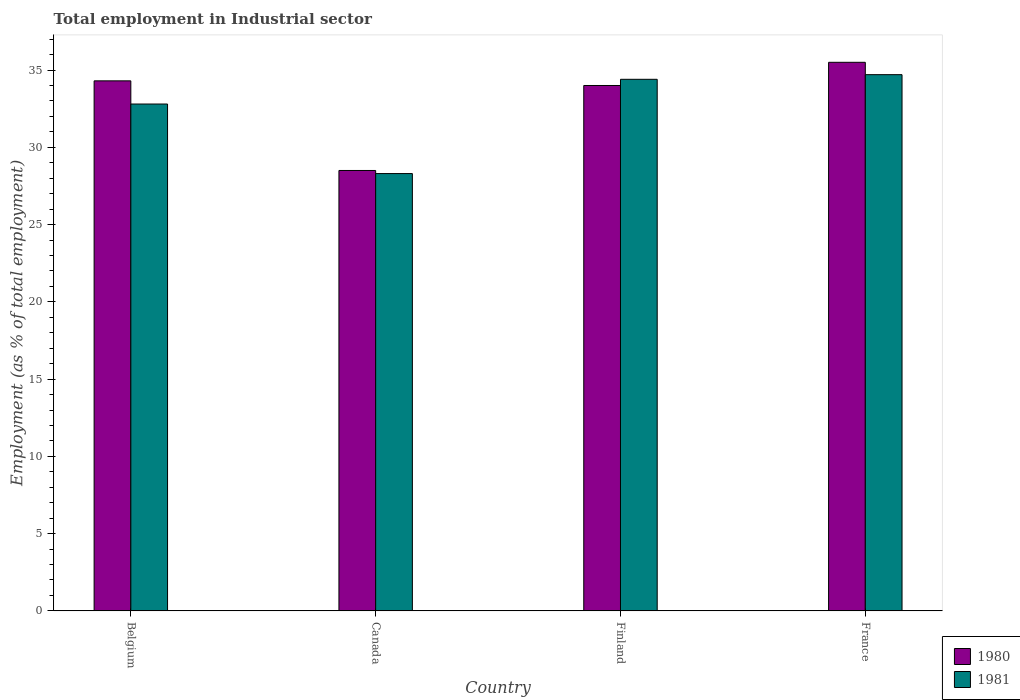How many different coloured bars are there?
Ensure brevity in your answer.  2. How many groups of bars are there?
Provide a succinct answer. 4. Are the number of bars per tick equal to the number of legend labels?
Your response must be concise. Yes. How many bars are there on the 2nd tick from the left?
Offer a very short reply. 2. How many bars are there on the 3rd tick from the right?
Provide a succinct answer. 2. In how many cases, is the number of bars for a given country not equal to the number of legend labels?
Provide a short and direct response. 0. What is the employment in industrial sector in 1981 in Canada?
Your response must be concise. 28.3. Across all countries, what is the maximum employment in industrial sector in 1981?
Give a very brief answer. 34.7. Across all countries, what is the minimum employment in industrial sector in 1981?
Your answer should be very brief. 28.3. What is the total employment in industrial sector in 1981 in the graph?
Provide a succinct answer. 130.2. What is the difference between the employment in industrial sector in 1981 in Belgium and that in France?
Keep it short and to the point. -1.9. What is the difference between the employment in industrial sector in 1981 in Finland and the employment in industrial sector in 1980 in Canada?
Offer a terse response. 5.9. What is the average employment in industrial sector in 1981 per country?
Offer a terse response. 32.55. What is the difference between the employment in industrial sector of/in 1980 and employment in industrial sector of/in 1981 in Canada?
Your answer should be compact. 0.2. What is the ratio of the employment in industrial sector in 1981 in Belgium to that in France?
Offer a very short reply. 0.95. What is the difference between the highest and the second highest employment in industrial sector in 1980?
Give a very brief answer. -1.2. What is the difference between the highest and the lowest employment in industrial sector in 1981?
Offer a terse response. 6.4. Is the sum of the employment in industrial sector in 1980 in Belgium and Canada greater than the maximum employment in industrial sector in 1981 across all countries?
Make the answer very short. Yes. What does the 2nd bar from the left in Canada represents?
Keep it short and to the point. 1981. What does the 2nd bar from the right in Belgium represents?
Provide a short and direct response. 1980. How many bars are there?
Your response must be concise. 8. Are all the bars in the graph horizontal?
Your response must be concise. No. How many countries are there in the graph?
Ensure brevity in your answer.  4. Are the values on the major ticks of Y-axis written in scientific E-notation?
Your response must be concise. No. What is the title of the graph?
Give a very brief answer. Total employment in Industrial sector. Does "1985" appear as one of the legend labels in the graph?
Provide a succinct answer. No. What is the label or title of the Y-axis?
Offer a very short reply. Employment (as % of total employment). What is the Employment (as % of total employment) of 1980 in Belgium?
Offer a very short reply. 34.3. What is the Employment (as % of total employment) in 1981 in Belgium?
Offer a very short reply. 32.8. What is the Employment (as % of total employment) in 1981 in Canada?
Your answer should be compact. 28.3. What is the Employment (as % of total employment) in 1980 in Finland?
Ensure brevity in your answer.  34. What is the Employment (as % of total employment) of 1981 in Finland?
Ensure brevity in your answer.  34.4. What is the Employment (as % of total employment) of 1980 in France?
Ensure brevity in your answer.  35.5. What is the Employment (as % of total employment) of 1981 in France?
Make the answer very short. 34.7. Across all countries, what is the maximum Employment (as % of total employment) in 1980?
Your response must be concise. 35.5. Across all countries, what is the maximum Employment (as % of total employment) of 1981?
Your answer should be very brief. 34.7. Across all countries, what is the minimum Employment (as % of total employment) in 1981?
Make the answer very short. 28.3. What is the total Employment (as % of total employment) in 1980 in the graph?
Provide a short and direct response. 132.3. What is the total Employment (as % of total employment) in 1981 in the graph?
Keep it short and to the point. 130.2. What is the difference between the Employment (as % of total employment) of 1980 in Belgium and that in Canada?
Keep it short and to the point. 5.8. What is the difference between the Employment (as % of total employment) of 1980 in Belgium and that in France?
Provide a succinct answer. -1.2. What is the difference between the Employment (as % of total employment) of 1981 in Belgium and that in France?
Give a very brief answer. -1.9. What is the difference between the Employment (as % of total employment) of 1980 in Canada and that in Finland?
Make the answer very short. -5.5. What is the difference between the Employment (as % of total employment) of 1980 in Finland and that in France?
Ensure brevity in your answer.  -1.5. What is the difference between the Employment (as % of total employment) of 1980 in Belgium and the Employment (as % of total employment) of 1981 in Finland?
Ensure brevity in your answer.  -0.1. What is the difference between the Employment (as % of total employment) of 1980 in Belgium and the Employment (as % of total employment) of 1981 in France?
Give a very brief answer. -0.4. What is the difference between the Employment (as % of total employment) of 1980 in Finland and the Employment (as % of total employment) of 1981 in France?
Your answer should be compact. -0.7. What is the average Employment (as % of total employment) of 1980 per country?
Offer a terse response. 33.08. What is the average Employment (as % of total employment) of 1981 per country?
Provide a succinct answer. 32.55. What is the difference between the Employment (as % of total employment) in 1980 and Employment (as % of total employment) in 1981 in Belgium?
Offer a terse response. 1.5. What is the difference between the Employment (as % of total employment) in 1980 and Employment (as % of total employment) in 1981 in Canada?
Your response must be concise. 0.2. What is the difference between the Employment (as % of total employment) in 1980 and Employment (as % of total employment) in 1981 in Finland?
Your answer should be compact. -0.4. What is the ratio of the Employment (as % of total employment) of 1980 in Belgium to that in Canada?
Your answer should be very brief. 1.2. What is the ratio of the Employment (as % of total employment) in 1981 in Belgium to that in Canada?
Make the answer very short. 1.16. What is the ratio of the Employment (as % of total employment) of 1980 in Belgium to that in Finland?
Provide a succinct answer. 1.01. What is the ratio of the Employment (as % of total employment) of 1981 in Belgium to that in Finland?
Make the answer very short. 0.95. What is the ratio of the Employment (as % of total employment) in 1980 in Belgium to that in France?
Your answer should be compact. 0.97. What is the ratio of the Employment (as % of total employment) in 1981 in Belgium to that in France?
Your response must be concise. 0.95. What is the ratio of the Employment (as % of total employment) in 1980 in Canada to that in Finland?
Offer a very short reply. 0.84. What is the ratio of the Employment (as % of total employment) of 1981 in Canada to that in Finland?
Keep it short and to the point. 0.82. What is the ratio of the Employment (as % of total employment) in 1980 in Canada to that in France?
Provide a short and direct response. 0.8. What is the ratio of the Employment (as % of total employment) in 1981 in Canada to that in France?
Keep it short and to the point. 0.82. What is the ratio of the Employment (as % of total employment) of 1980 in Finland to that in France?
Your answer should be compact. 0.96. What is the ratio of the Employment (as % of total employment) of 1981 in Finland to that in France?
Keep it short and to the point. 0.99. What is the difference between the highest and the second highest Employment (as % of total employment) of 1981?
Provide a short and direct response. 0.3. What is the difference between the highest and the lowest Employment (as % of total employment) of 1981?
Keep it short and to the point. 6.4. 